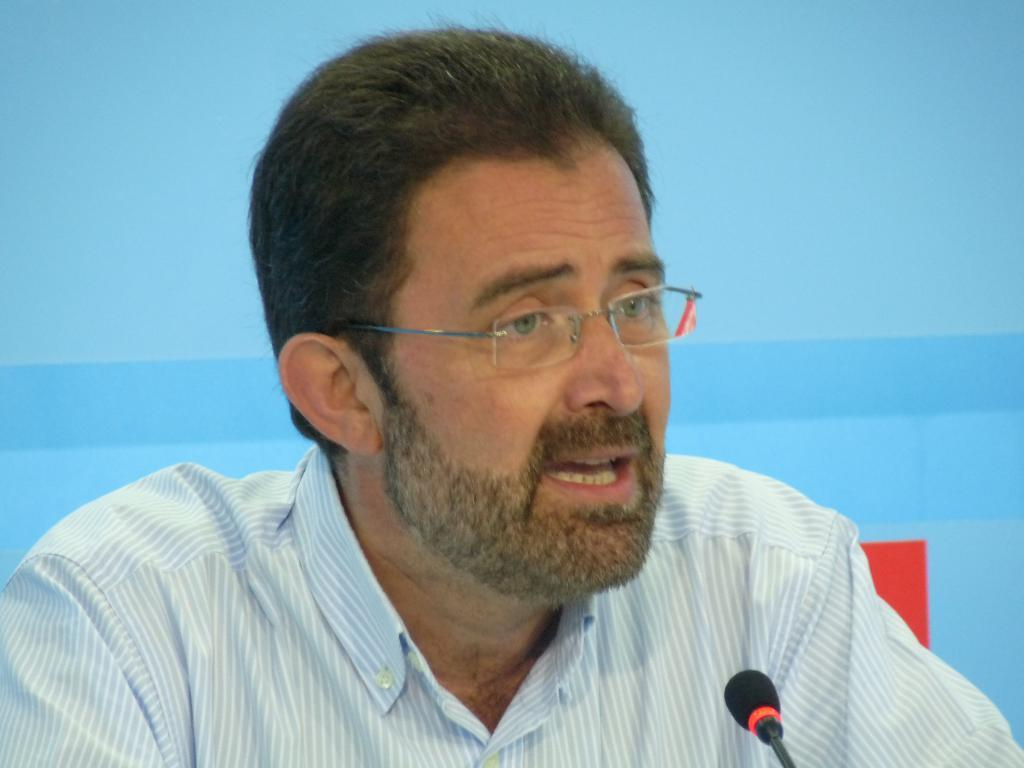What is the man in the image doing? The man is sitting in the image. What object is located at the bottom of the image? There is a microphone at the bottom of the image. What can be seen in the background of the image? There is a wall in the background of the image. What type of furniture is visible in the image? There is no furniture present in the image. Can you see the ocean in the background of the image? No, the background of the image features a wall, not the ocean. 